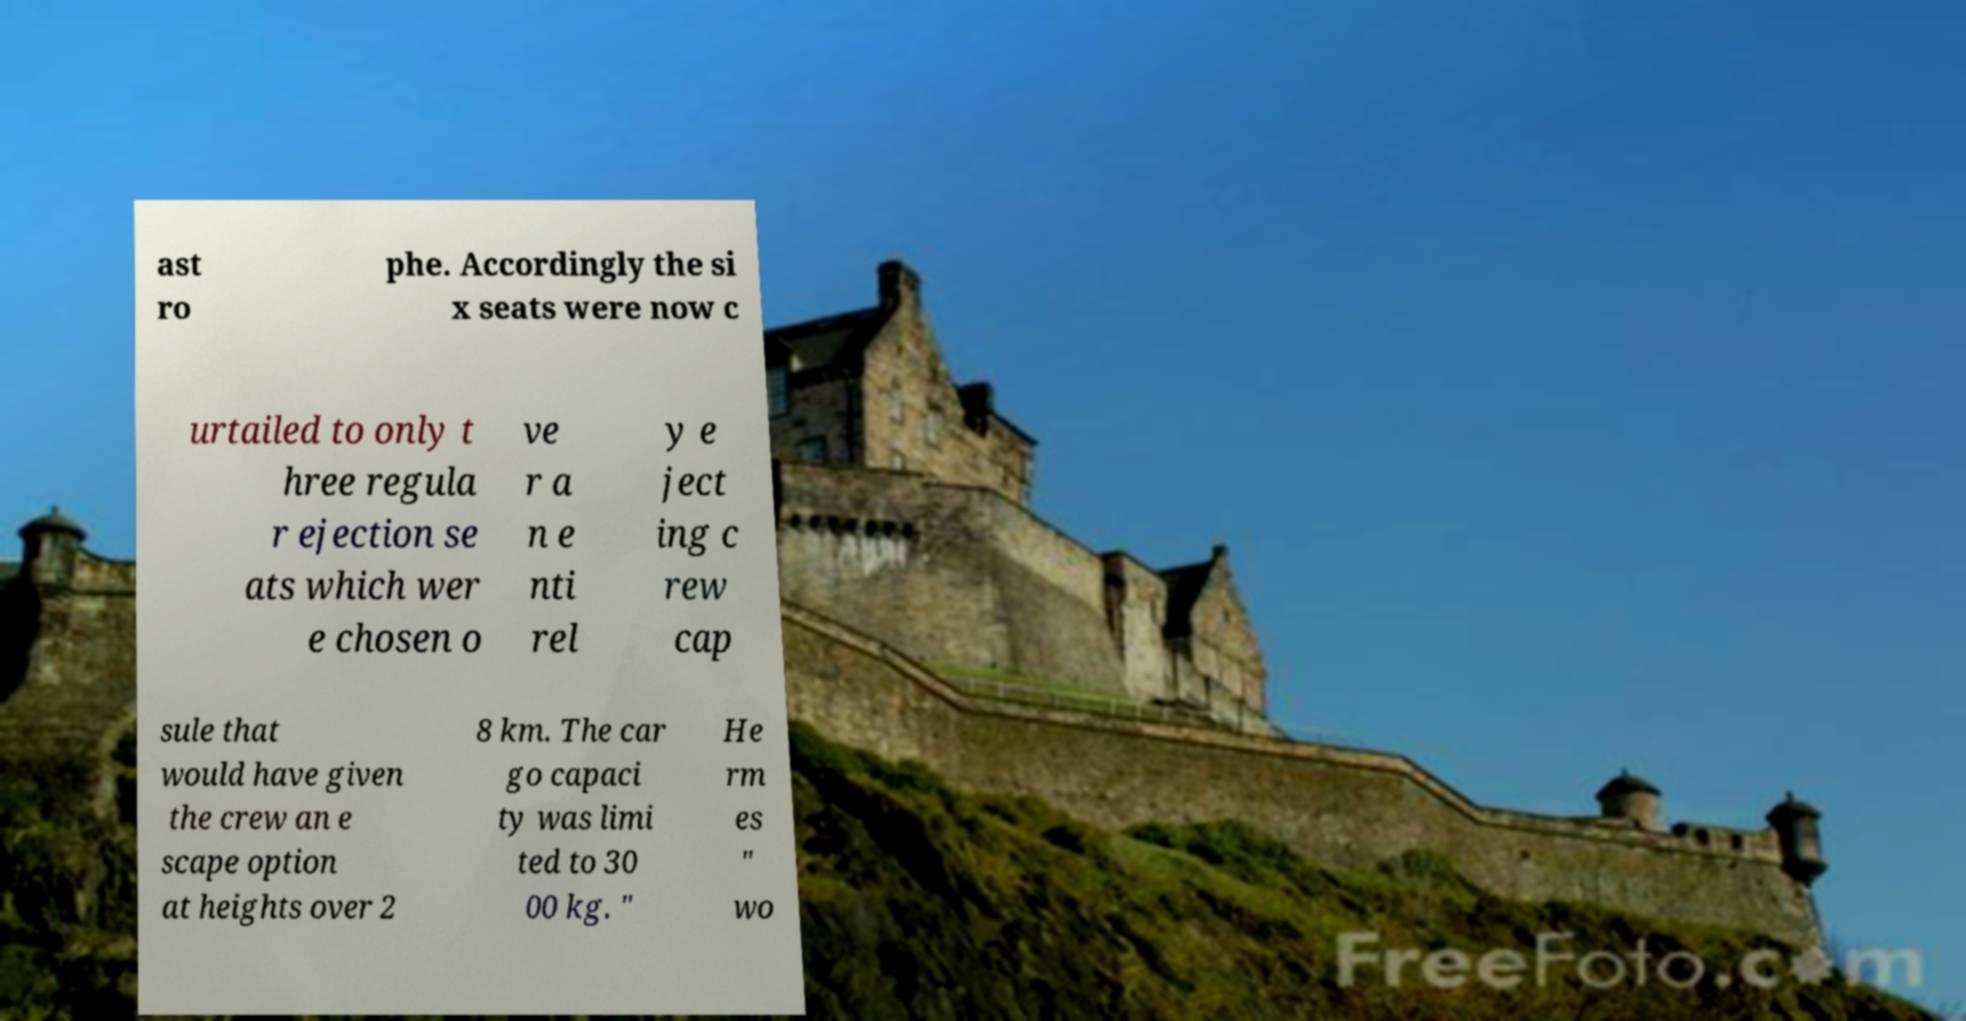What messages or text are displayed in this image? I need them in a readable, typed format. ast ro phe. Accordingly the si x seats were now c urtailed to only t hree regula r ejection se ats which wer e chosen o ve r a n e nti rel y e ject ing c rew cap sule that would have given the crew an e scape option at heights over 2 8 km. The car go capaci ty was limi ted to 30 00 kg. " He rm es " wo 